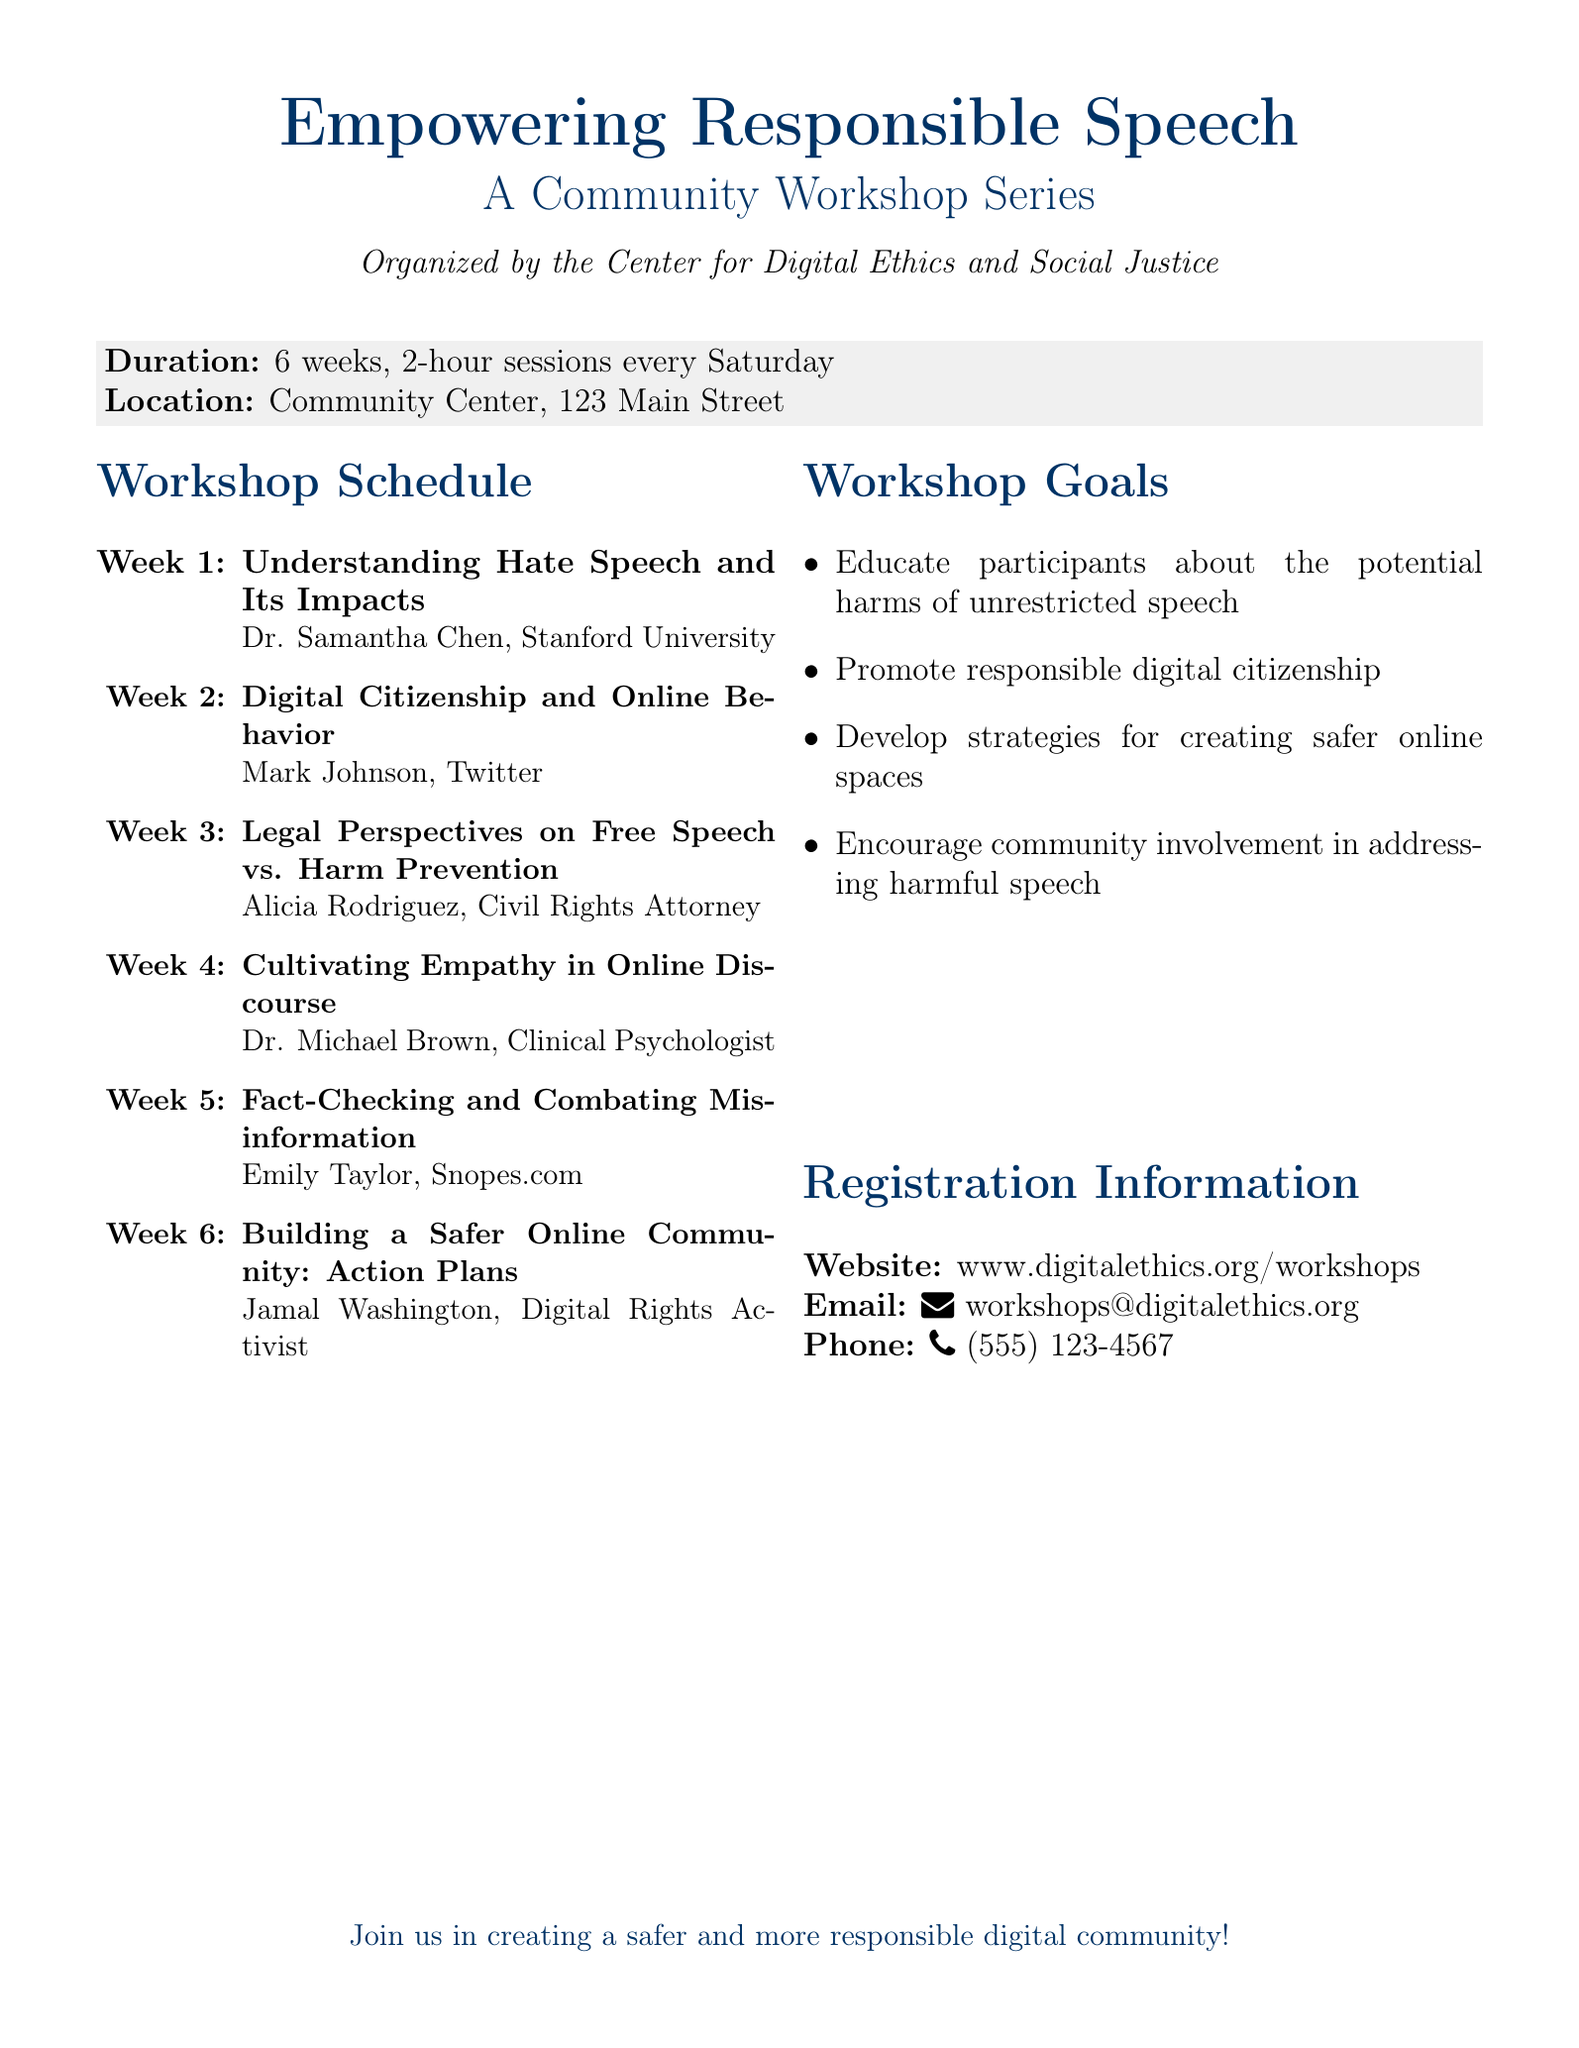What is the duration of the workshop series? The duration is specified in the document as 6 weeks, with sessions held every Saturday.
Answer: 6 weeks Who is the speaker for the workshop on hate speech? The document lists Dr. Samantha Chen from Stanford University as the speaker for this topic.
Answer: Dr. Samantha Chen How many sessions are included in the workshop? The total number of sessions is indicated by the weekly schedule outlined in the document.
Answer: 6 sessions What is the location of the workshop? The address for the workshop is clearly stated in the document.
Answer: Community Center, 123 Main Street What is one of the goals of the workshop series? The goals of the workshops are listed in the document, including educating about harmful speech.
Answer: Educate participants about the potential harms of unrestricted speech Who is the speaker focusing on digital citizenship? The document mentions Mark Johnson as the speaker for this particular session.
Answer: Mark Johnson On what date is the first workshop scheduled? The document outlines that sessions occur every Saturday but does not specify a date; it must be inferred as the first Saturday of the series.
Answer: First Saturday What is the email contact for registration? The document provides specific email information for participants to reach out regarding registration and inquiries.
Answer: workshops@digitalethics.org What is the focus of the last workshop? The last workshop's title provides insight into its focus area as stated in the document.
Answer: Building a Safer Online Community: Action Plans 